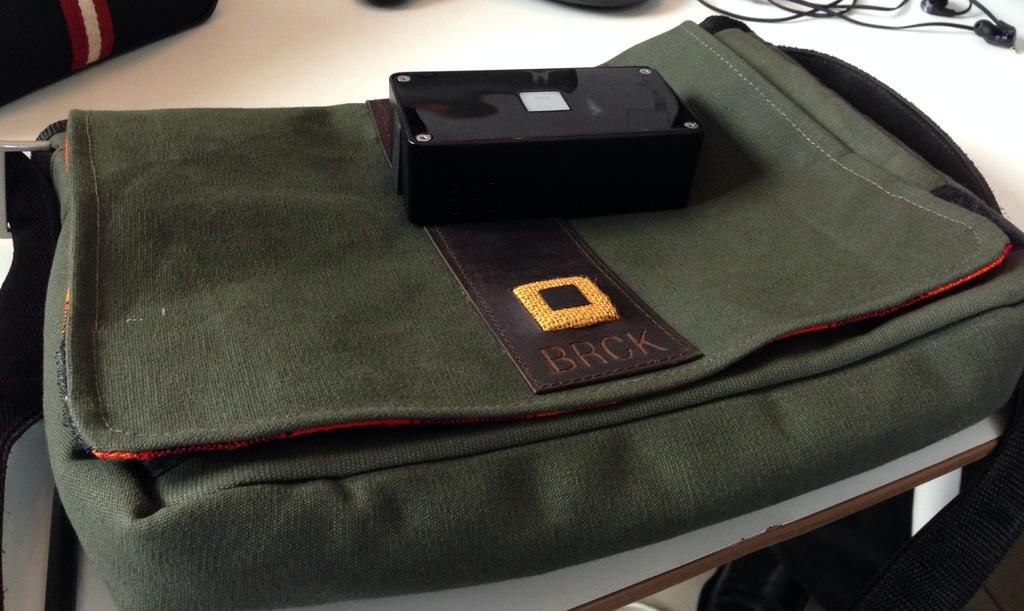What object can be seen in the image that might be used for carrying items? There is a bag in the image that might be used for carrying items. What electronic device is visible in the image? There are earphones in the image. What color is the table in the image? The table is white in color. What type of jeans can be seen on the floor in the image? There is no mention of jeans or a floor in the provided facts, so it cannot be determined if jeans are present in the image. 